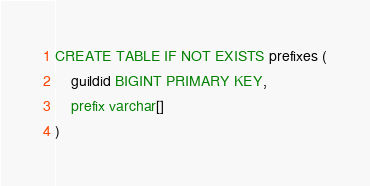<code> <loc_0><loc_0><loc_500><loc_500><_SQL_>CREATE TABLE IF NOT EXISTS prefixes (
    guildid BIGINT PRIMARY KEY,
    prefix varchar[]
)</code> 